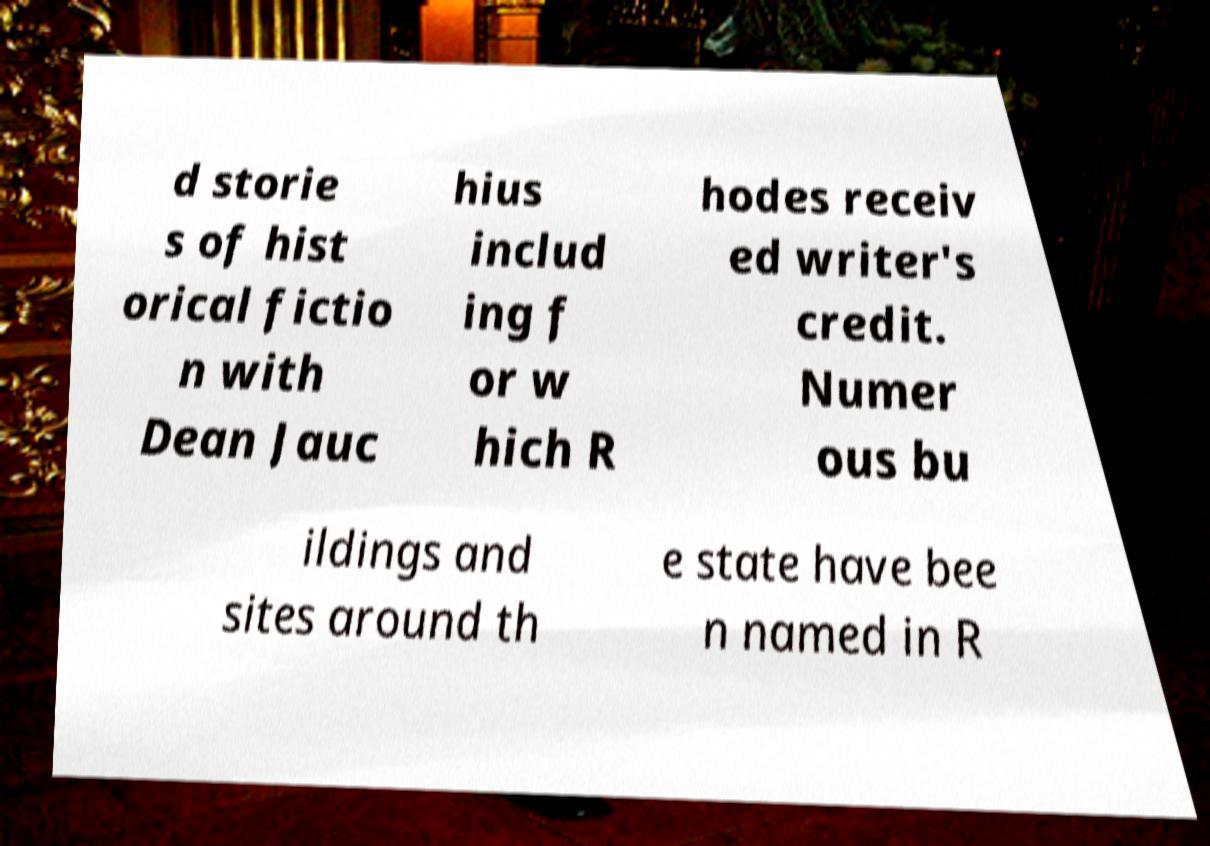For documentation purposes, I need the text within this image transcribed. Could you provide that? d storie s of hist orical fictio n with Dean Jauc hius includ ing f or w hich R hodes receiv ed writer's credit. Numer ous bu ildings and sites around th e state have bee n named in R 